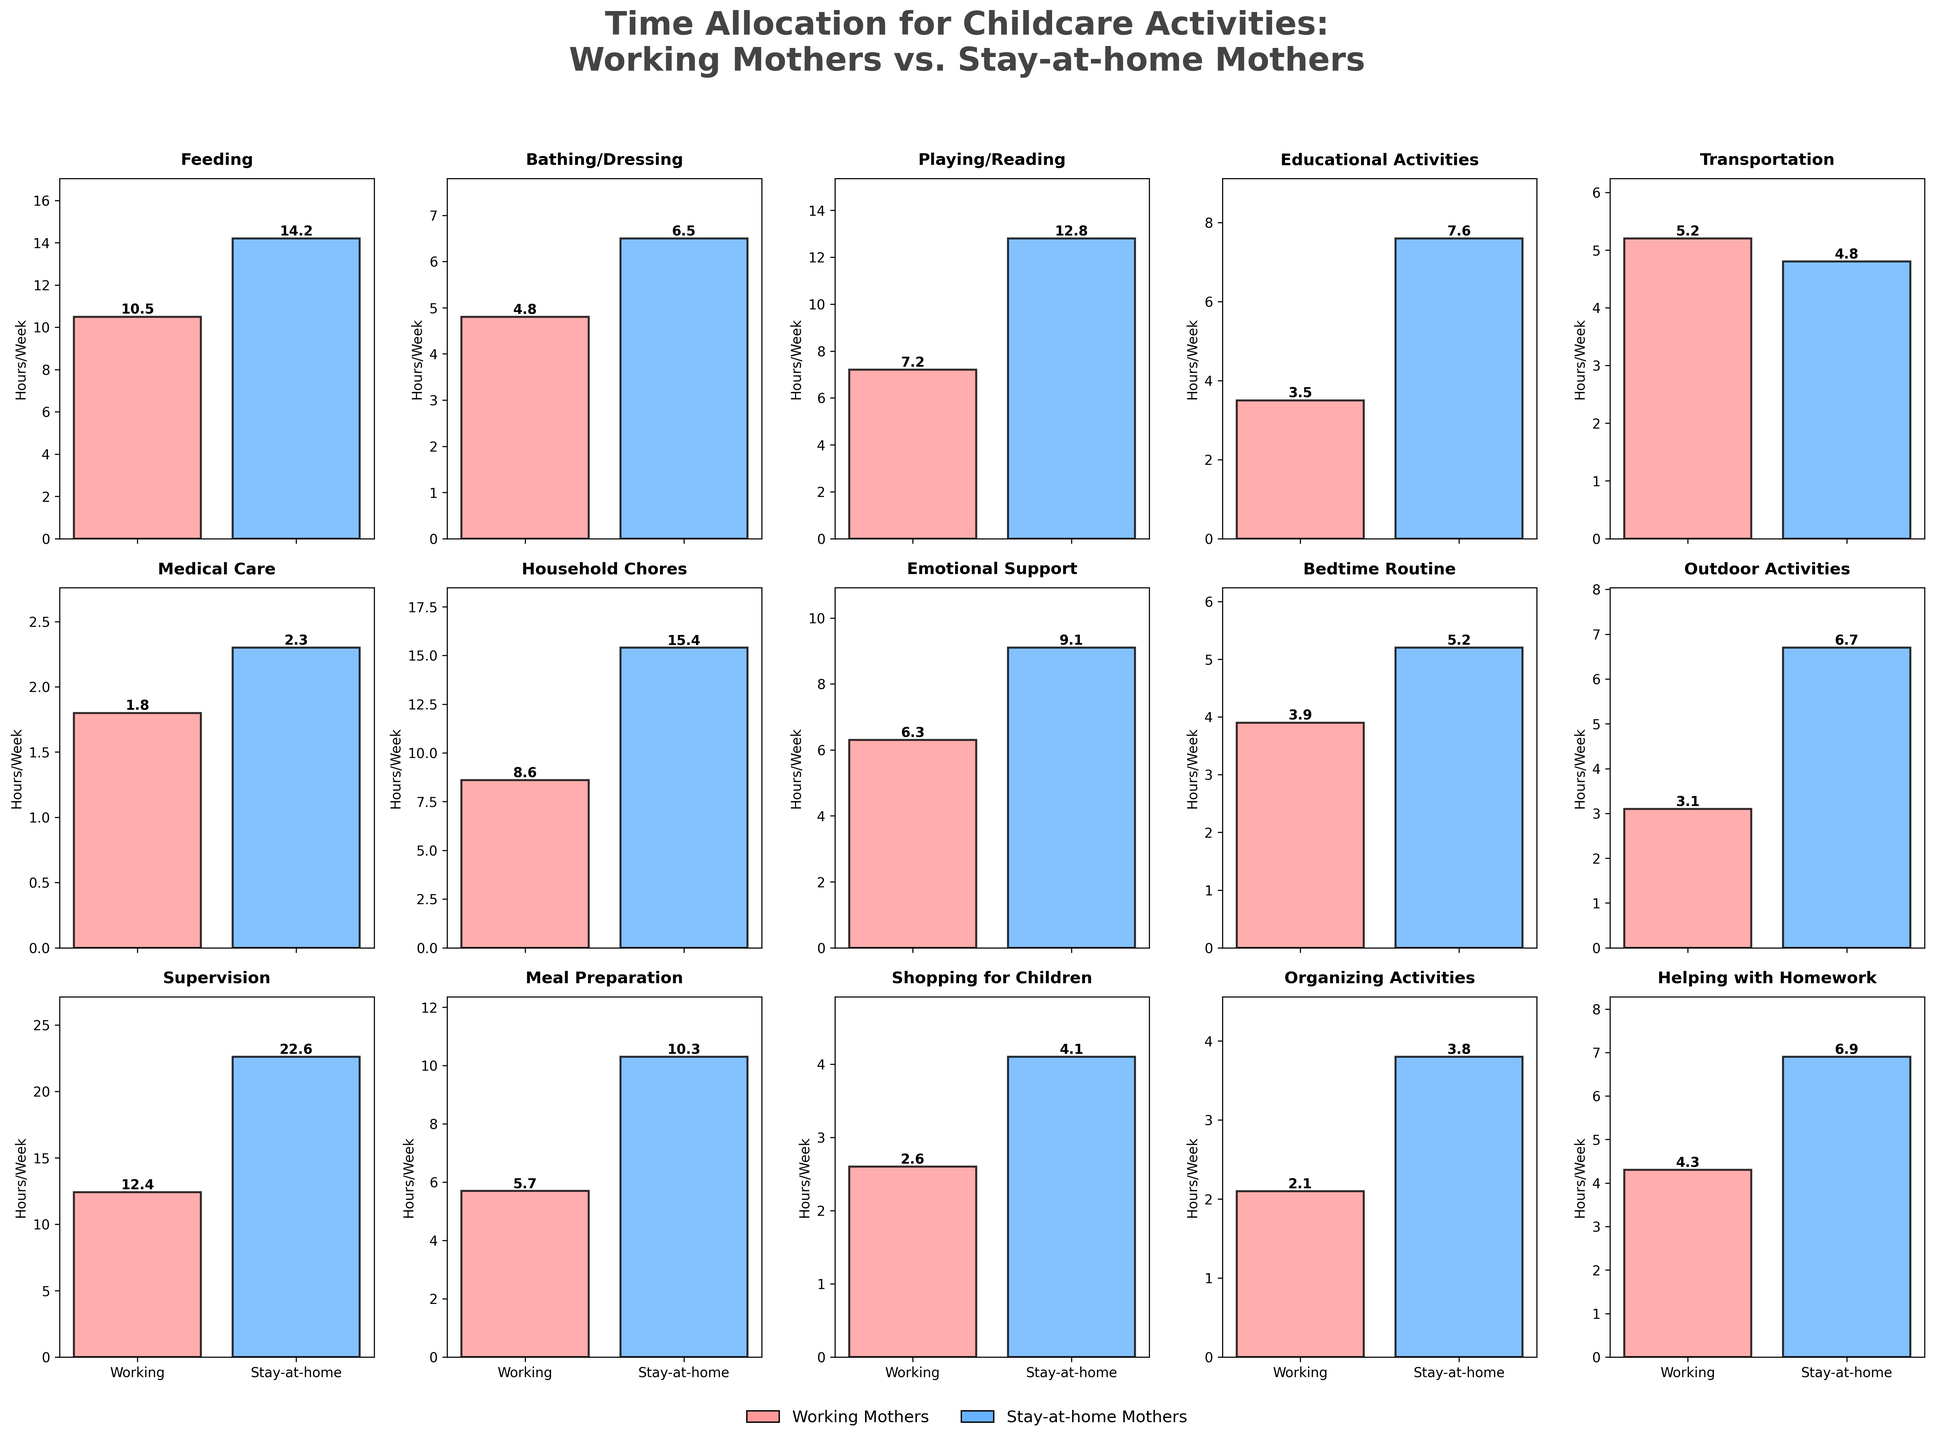What's the total time spent by working mothers on Feeding and Playing/Reading? Combine the hours for Feeding (10.5) and Playing/Reading (7.2). Therefore, 10.5 + 7.2 = 17.7 hours/week.
Answer: 17.7 hours/week Which group of mothers spends more time on Meal Preparation? Compare the time spent by both groups: Working Mothers spend 5.7 hours/week, while Stay-at-home Mothers spend 10.3 hours/week. Stay-at-home mothers spend more time.
Answer: Stay-at-home mothers What is the average time spent by stay-at-home mothers on Outdoor Activities and Emotional Support? Add the time spent on Outdoor Activities (6.7) and Emotional Support (9.1), and then divide by 2. (6.7 + 9.1) / 2 = 7.9 hours/week.
Answer: 7.9 hours/week How much more time do stay-at-home mothers spend on Educational Activities compared to working mothers? Subtract the time working mothers spend (3.5) from the time stay-at-home mothers spend (7.6). 7.6 - 3.5 = 4.1 hours/week.
Answer: 4.1 hours/week What is the difference in time spent on Supervision between working and stay-at-home mothers? Subtract the time working mothers spend on Supervision (12.4) from the time stay-at-home mothers spend (22.6). 22.6 - 12.4 = 10.2 hours/week.
Answer: 10.2 hours/week Which activity has the smallest difference in time spent between working and stay-at-home mothers? Compare the differences for each activity: Feeding (3.7), Bathing/Dressing (1.7), Playing/Reading (5.6), Educational Activities (4.1), Transportation (-0.4), Medical Care (0.5), Household Chores (6.8), Emotional Support (2.8), Bedtime Routine (1.3), Outdoor Activities (3.6), Supervision (10.2), Meal Preparation (4.6), Shopping for Children (1.5), Organizing Activities (1.7), Helping with Homework (2.6). The smallest difference is for Transportation, with -0.4.
Answer: Transportation Which group of mothers spends more time on Activities in total if we consider only Feeding, Educational Activities, and Household Chores? Sum the time for each activity for both groups: Working Mothers: 10.5 + 3.5 + 8.6 = 22.6 hours/week; Stay-at-home Mothers: 14.2 + 7.6 + 15.4 = 37.2 hours/week. Stay-at-home mothers spend more time.
Answer: Stay-at-home mothers Which activity do working mothers spend the least time on? Look for the minimum time value for working mothers across all activities: Medical Care (1.8 hours/week).
Answer: Medical Care In which activity do stay-at-home mothers spend almost double the time than working mothers? Compare each activity: Feeding (14.2 vs. 10.5), Bathing/Dressing (6.5 vs. 4.8), Playing/Reading (12.8 vs. 7.2), Educational Activities (7.6 vs. 3.5), Transportation (4.8 vs. 5.2), Medical Care (2.3 vs. 1.8), Household Chores (15.4 vs. 8.6), Emotional Support (9.1 vs. 6.3), Bedtime Routine (5.2 vs. 3.9), Outdoor Activities (6.7 vs. 3.1), Supervision (22.6 vs. 12.4), Meal Preparation (10.3 vs. 5.7), Shopping for Children (4.1 vs. 2.6), Organizing Activities (3.8 vs. 2.1), Helping with Homework (6.9 vs. 4.3). Household Chores (15.4 is nearly double 8.6).
Answer: Household Chores 